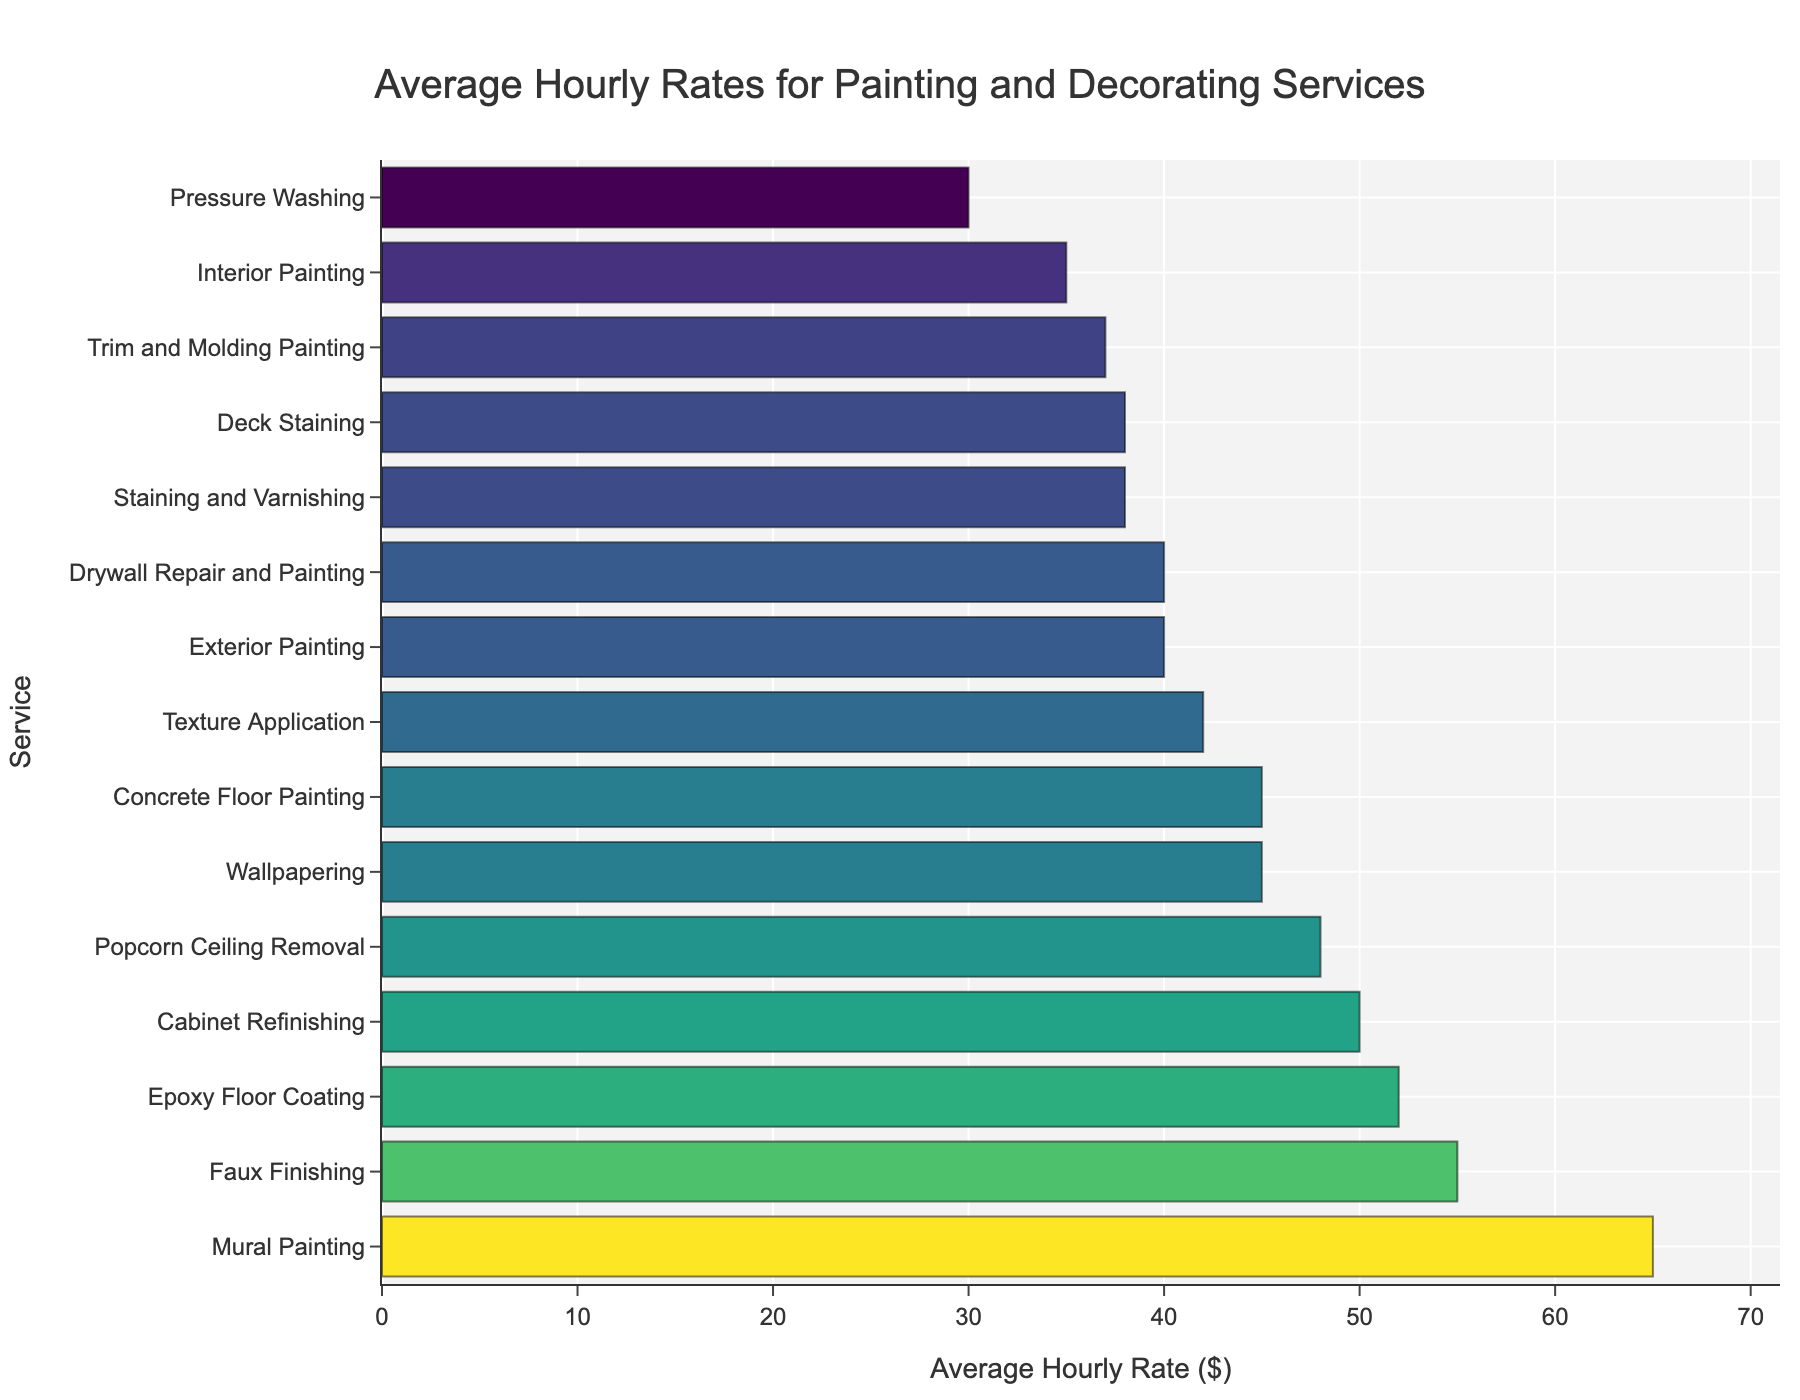Which service has the highest average hourly rate? By looking at the bars, Mural Painting has the longest bar, indicating it has the highest average hourly rate.
Answer: Mural Painting Which service has a lower average hourly rate: Exterior Painting or Interior Painting? Compare the lengths of the bars for Exterior Painting and Interior Painting. Interior Painting has a shorter bar than Exterior Painting.
Answer: Interior Painting What's the average hourly rate for Wallpapering? Check the corresponding value next to the bar labeled 'Wallpapering'.
Answer: 45 Is the rate for Cabinet Refinishing greater than or less than Concrete Floor Painting? Observe the length of the bars for Cabinet Refinishing and Concrete Floor Painting. Cabinet Refinishing's bar is longer than Concrete Floor Painting's bar.
Answer: Greater How much more do you charge for Mural Painting compared to Pressure Washing? The average hourly rate for Mural Painting is $65 and for Pressure Washing is $30. The difference is $65 - $30.
Answer: 35 Rank the following services from highest to lowest average hourly rate: Faux Finishing, Texture Application, Drywall Repair and Painting. Compare the bar lengths of Faux Finishing, Texture Application, and Drywall Repair and Painting. The order from longest to shortest is Faux Finishing, Texture Application, and Drywall Repair and Painting.
Answer: Faux Finishing, Texture Application, Drywall Repair and Painting Which type of service has an hourly rate closest to $40? By examining the figure, Exterior Painting and Drywall Repair and Painting both are $40, indicating they are the closest to this rate.
Answer: Exterior Painting, Drywall Repair and Painting What's the combined average hourly rate for Trim and Molding Painting and Deck Staining? Trim and Molding Painting has an hourly rate of $37, and Deck Staining is $38. Adding $37 + $38 gives $75.
Answer: 75 Are there any services with the same average hourly rate? By looking at the figure, Staining and Varnishing and Deck Staining have the same bar length, indicating the same hourly rate of $38.
Answer: Staining and Varnishing, Deck Staining Which has a higher average hourly rate: Epoxy Floor Coating or Concrete Floor Painting? Compare the bar lengths of Epoxy Floor Coating and Concrete Floor Painting. Epoxy Floor Coating's bar is longer.
Answer: Epoxy Floor Coating 